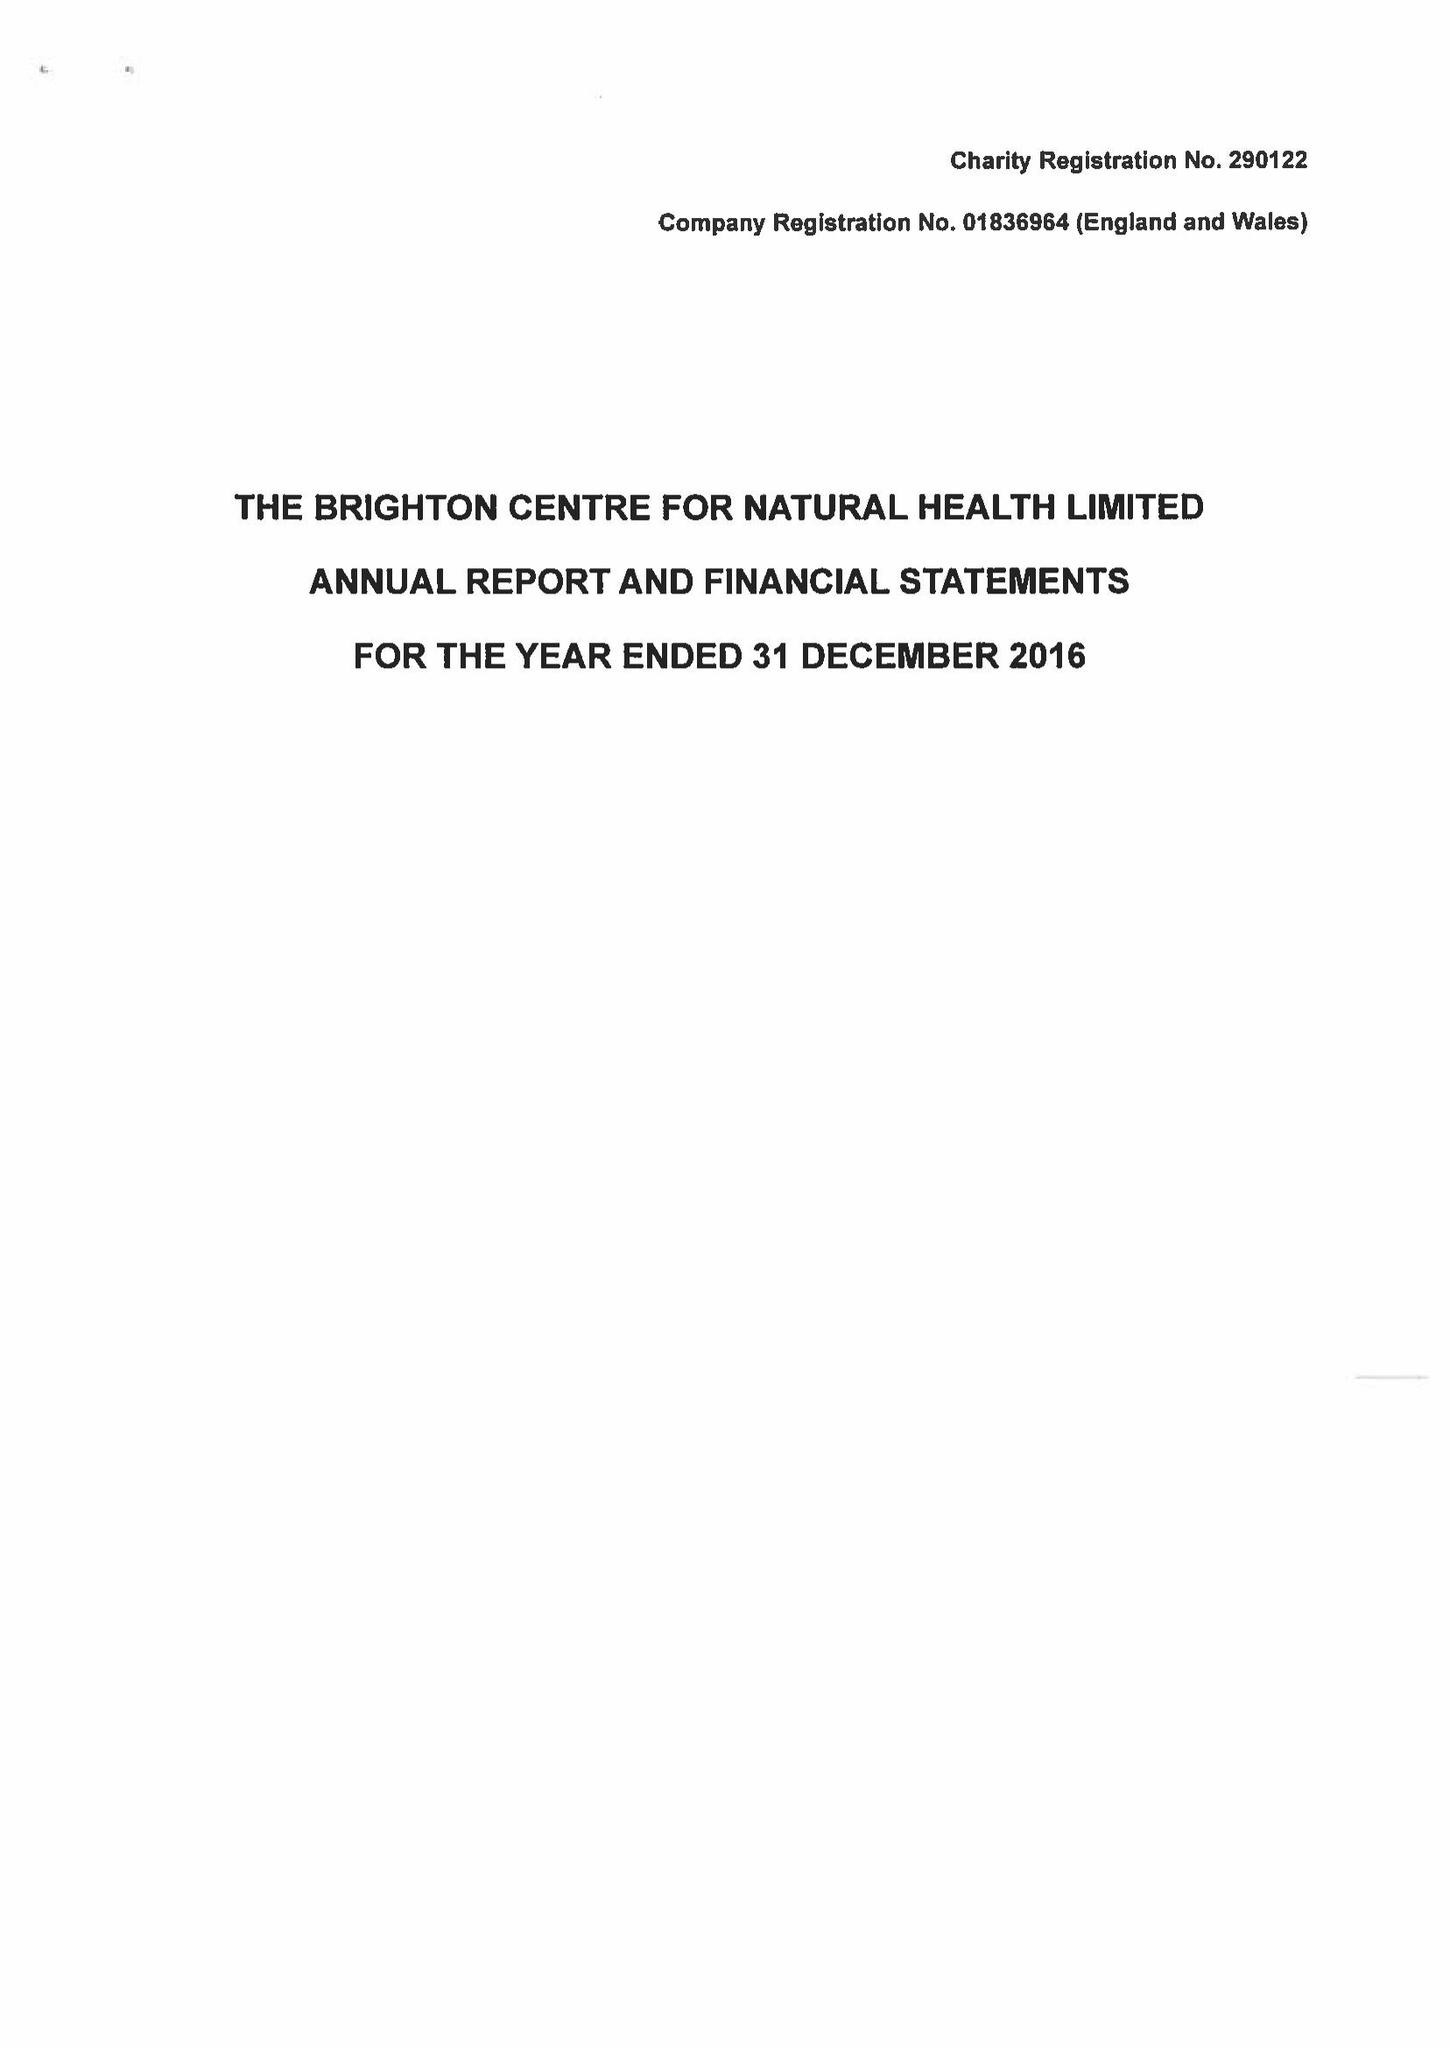What is the value for the report_date?
Answer the question using a single word or phrase. 2016-12-31 